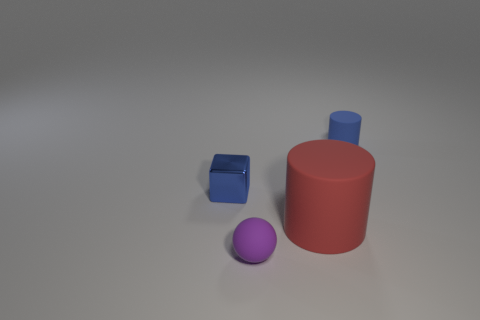Add 4 big yellow blocks. How many objects exist? 8 Subtract all tiny rubber cylinders. Subtract all tiny things. How many objects are left? 0 Add 2 small blue objects. How many small blue objects are left? 4 Add 4 small blue cylinders. How many small blue cylinders exist? 5 Subtract 0 green spheres. How many objects are left? 4 